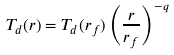Convert formula to latex. <formula><loc_0><loc_0><loc_500><loc_500>T _ { d } ( r ) = T _ { d } ( r _ { f } ) \left ( \frac { r } { r _ { f } } \right ) ^ { - q }</formula> 